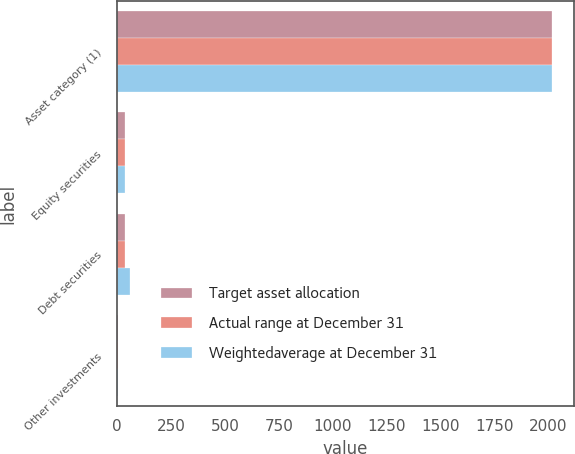<chart> <loc_0><loc_0><loc_500><loc_500><stacked_bar_chart><ecel><fcel>Asset category (1)<fcel>Equity securities<fcel>Debt securities<fcel>Other investments<nl><fcel>Target asset allocation<fcel>2018<fcel>37<fcel>38<fcel>5<nl><fcel>Actual range at December 31<fcel>2017<fcel>38<fcel>38<fcel>4<nl><fcel>Weightedaverage at December 31<fcel>2017<fcel>38<fcel>58<fcel>4<nl></chart> 